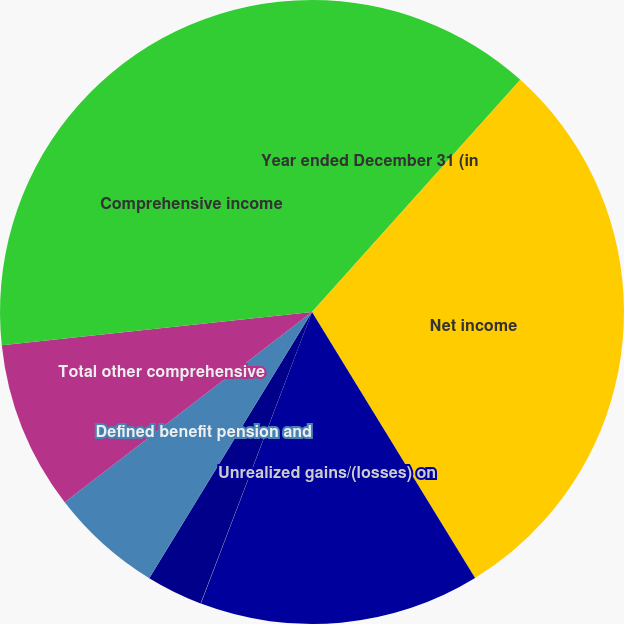Convert chart. <chart><loc_0><loc_0><loc_500><loc_500><pie_chart><fcel>Year ended December 31 (in<fcel>Net income<fcel>Unrealized gains/(losses) on<fcel>Translation adjustments net of<fcel>Cash flow hedges<fcel>Defined benefit pension and<fcel>Total other comprehensive<fcel>Comprehensive income<nl><fcel>11.64%<fcel>29.61%<fcel>14.55%<fcel>0.02%<fcel>2.92%<fcel>5.83%<fcel>8.74%<fcel>26.7%<nl></chart> 